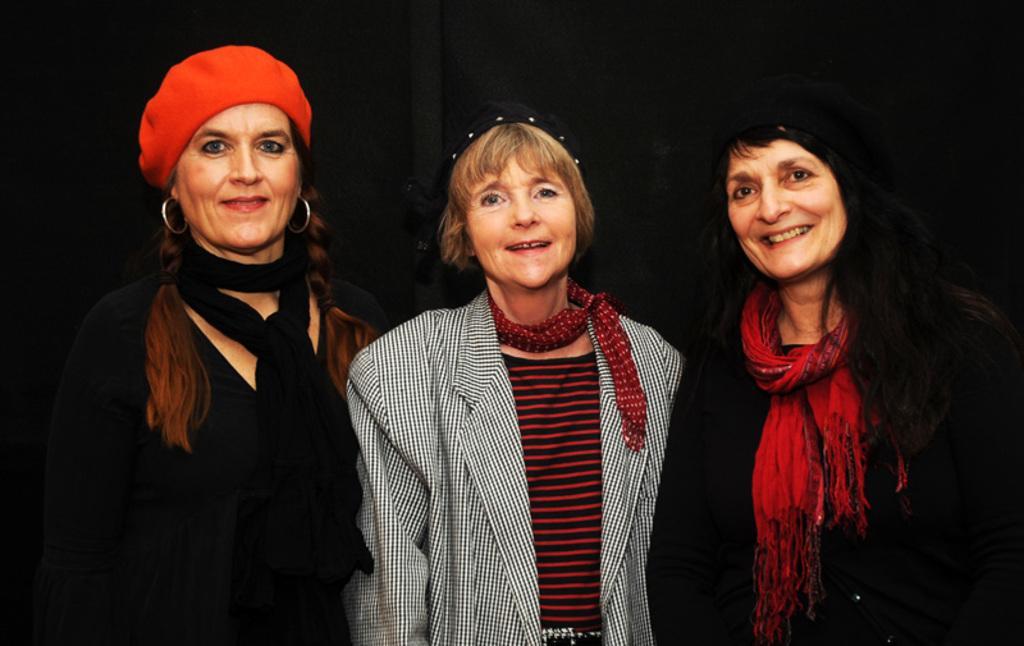How would you summarize this image in a sentence or two? In the picture there are three women present standing together. 